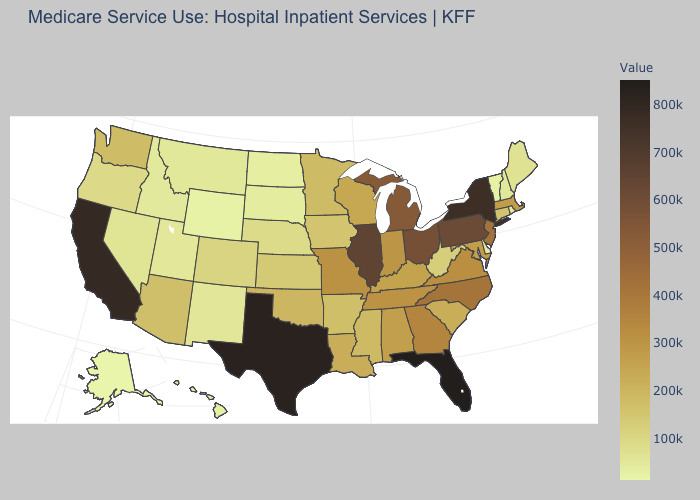Which states have the highest value in the USA?
Concise answer only. Florida. Which states have the lowest value in the USA?
Keep it brief. Alaska. Does Arizona have a lower value than North Carolina?
Short answer required. Yes. Does Alaska have the lowest value in the USA?
Answer briefly. Yes. Among the states that border Nebraska , which have the lowest value?
Concise answer only. Wyoming. Does Minnesota have the highest value in the MidWest?
Short answer required. No. Among the states that border Connecticut , does Massachusetts have the lowest value?
Answer briefly. No. Does the map have missing data?
Quick response, please. No. Among the states that border Washington , which have the highest value?
Keep it brief. Oregon. 